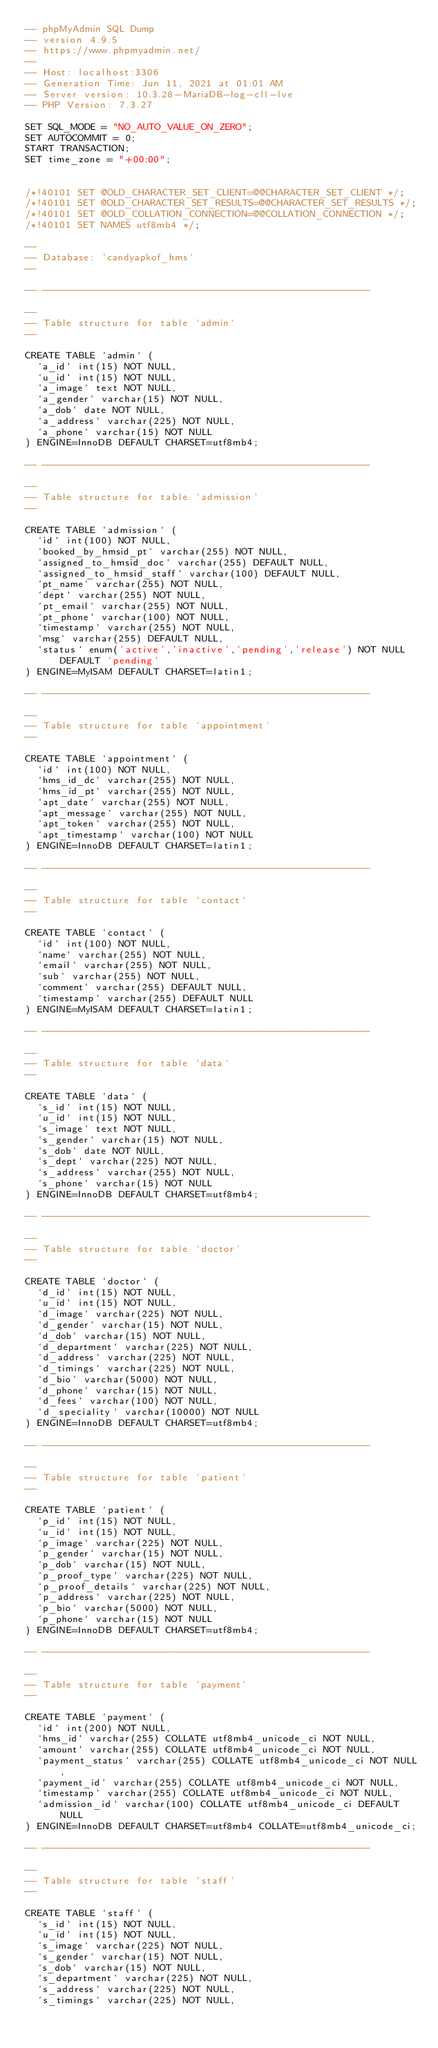Convert code to text. <code><loc_0><loc_0><loc_500><loc_500><_SQL_>-- phpMyAdmin SQL Dump
-- version 4.9.5
-- https://www.phpmyadmin.net/
--
-- Host: localhost:3306
-- Generation Time: Jun 11, 2021 at 01:01 AM
-- Server version: 10.3.28-MariaDB-log-cll-lve
-- PHP Version: 7.3.27

SET SQL_MODE = "NO_AUTO_VALUE_ON_ZERO";
SET AUTOCOMMIT = 0;
START TRANSACTION;
SET time_zone = "+00:00";


/*!40101 SET @OLD_CHARACTER_SET_CLIENT=@@CHARACTER_SET_CLIENT */;
/*!40101 SET @OLD_CHARACTER_SET_RESULTS=@@CHARACTER_SET_RESULTS */;
/*!40101 SET @OLD_COLLATION_CONNECTION=@@COLLATION_CONNECTION */;
/*!40101 SET NAMES utf8mb4 */;

--
-- Database: `candyapkof_hms`
--

-- --------------------------------------------------------

--
-- Table structure for table `admin`
--

CREATE TABLE `admin` (
  `a_id` int(15) NOT NULL,
  `u_id` int(15) NOT NULL,
  `a_image` text NOT NULL,
  `a_gender` varchar(15) NOT NULL,
  `a_dob` date NOT NULL,
  `a_address` varchar(225) NOT NULL,
  `a_phone` varchar(15) NOT NULL
) ENGINE=InnoDB DEFAULT CHARSET=utf8mb4;

-- --------------------------------------------------------

--
-- Table structure for table `admission`
--

CREATE TABLE `admission` (
  `id` int(100) NOT NULL,
  `booked_by_hmsid_pt` varchar(255) NOT NULL,
  `assigned_to_hmsid_doc` varchar(255) DEFAULT NULL,
  `assigned_to_hmsid_staff` varchar(100) DEFAULT NULL,
  `pt_name` varchar(255) NOT NULL,
  `dept` varchar(255) NOT NULL,
  `pt_email` varchar(255) NOT NULL,
  `pt_phone` varchar(100) NOT NULL,
  `timestamp` varchar(255) NOT NULL,
  `msg` varchar(255) DEFAULT NULL,
  `status` enum('active','inactive','pending','release') NOT NULL DEFAULT 'pending'
) ENGINE=MyISAM DEFAULT CHARSET=latin1;

-- --------------------------------------------------------

--
-- Table structure for table `appointment`
--

CREATE TABLE `appointment` (
  `id` int(100) NOT NULL,
  `hms_id_dc` varchar(255) NOT NULL,
  `hms_id_pt` varchar(255) NOT NULL,
  `apt_date` varchar(255) NOT NULL,
  `apt_message` varchar(255) NOT NULL,
  `apt_token` varchar(255) NOT NULL,
  `apt_timestamp` varchar(100) NOT NULL
) ENGINE=InnoDB DEFAULT CHARSET=latin1;

-- --------------------------------------------------------

--
-- Table structure for table `contact`
--

CREATE TABLE `contact` (
  `id` int(100) NOT NULL,
  `name` varchar(255) NOT NULL,
  `email` varchar(255) NOT NULL,
  `sub` varchar(255) NOT NULL,
  `comment` varchar(255) DEFAULT NULL,
  `timestamp` varchar(255) DEFAULT NULL
) ENGINE=MyISAM DEFAULT CHARSET=latin1;

-- --------------------------------------------------------

--
-- Table structure for table `data`
--

CREATE TABLE `data` (
  `s_id` int(15) NOT NULL,
  `u_id` int(15) NOT NULL,
  `s_image` text NOT NULL,
  `s_gender` varchar(15) NOT NULL,
  `s_dob` date NOT NULL,
  `s_dept` varchar(225) NOT NULL,
  `s_address` varchar(255) NOT NULL,
  `s_phone` varchar(15) NOT NULL
) ENGINE=InnoDB DEFAULT CHARSET=utf8mb4;

-- --------------------------------------------------------

--
-- Table structure for table `doctor`
--

CREATE TABLE `doctor` (
  `d_id` int(15) NOT NULL,
  `u_id` int(15) NOT NULL,
  `d_image` varchar(225) NOT NULL,
  `d_gender` varchar(15) NOT NULL,
  `d_dob` varchar(15) NOT NULL,
  `d_department` varchar(225) NOT NULL,
  `d_address` varchar(225) NOT NULL,
  `d_timings` varchar(225) NOT NULL,
  `d_bio` varchar(5000) NOT NULL,
  `d_phone` varchar(15) NOT NULL,
  `d_fees` varchar(100) NOT NULL,
  `d_speciality` varchar(10000) NOT NULL
) ENGINE=InnoDB DEFAULT CHARSET=utf8mb4;

-- --------------------------------------------------------

--
-- Table structure for table `patient`
--

CREATE TABLE `patient` (
  `p_id` int(15) NOT NULL,
  `u_id` int(15) NOT NULL,
  `p_image` varchar(225) NOT NULL,
  `p_gender` varchar(15) NOT NULL,
  `p_dob` varchar(15) NOT NULL,
  `p_proof_type` varchar(225) NOT NULL,
  `p_proof_details` varchar(225) NOT NULL,
  `p_address` varchar(225) NOT NULL,
  `p_bio` varchar(5000) NOT NULL,
  `p_phone` varchar(15) NOT NULL
) ENGINE=InnoDB DEFAULT CHARSET=utf8mb4;

-- --------------------------------------------------------

--
-- Table structure for table `payment`
--

CREATE TABLE `payment` (
  `id` int(200) NOT NULL,
  `hms_id` varchar(255) COLLATE utf8mb4_unicode_ci NOT NULL,
  `amount` varchar(255) COLLATE utf8mb4_unicode_ci NOT NULL,
  `payment_status` varchar(255) COLLATE utf8mb4_unicode_ci NOT NULL,
  `payment_id` varchar(255) COLLATE utf8mb4_unicode_ci NOT NULL,
  `timestamp` varchar(255) COLLATE utf8mb4_unicode_ci NOT NULL,
  `admission_id` varchar(100) COLLATE utf8mb4_unicode_ci DEFAULT NULL
) ENGINE=InnoDB DEFAULT CHARSET=utf8mb4 COLLATE=utf8mb4_unicode_ci;

-- --------------------------------------------------------

--
-- Table structure for table `staff`
--

CREATE TABLE `staff` (
  `s_id` int(15) NOT NULL,
  `u_id` int(15) NOT NULL,
  `s_image` varchar(225) NOT NULL,
  `s_gender` varchar(15) NOT NULL,
  `s_dob` varchar(15) NOT NULL,
  `s_department` varchar(225) NOT NULL,
  `s_address` varchar(225) NOT NULL,
  `s_timings` varchar(225) NOT NULL,</code> 